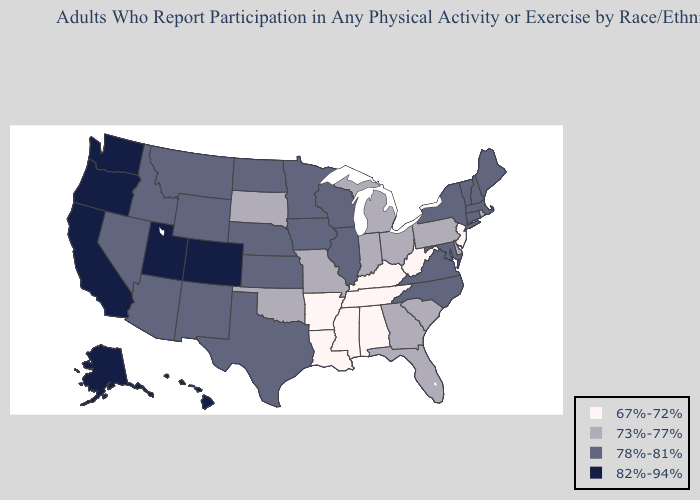Among the states that border Illinois , does Kentucky have the highest value?
Concise answer only. No. Name the states that have a value in the range 78%-81%?
Concise answer only. Arizona, Connecticut, Idaho, Illinois, Iowa, Kansas, Maine, Maryland, Massachusetts, Minnesota, Montana, Nebraska, Nevada, New Hampshire, New Mexico, New York, North Carolina, North Dakota, Texas, Vermont, Virginia, Wisconsin, Wyoming. Which states have the lowest value in the USA?
Concise answer only. Alabama, Arkansas, Kentucky, Louisiana, Mississippi, New Jersey, Tennessee, West Virginia. Name the states that have a value in the range 82%-94%?
Concise answer only. Alaska, California, Colorado, Hawaii, Oregon, Utah, Washington. What is the highest value in the Northeast ?
Quick response, please. 78%-81%. What is the value of Kansas?
Short answer required. 78%-81%. Among the states that border Florida , which have the lowest value?
Give a very brief answer. Alabama. Which states have the lowest value in the USA?
Be succinct. Alabama, Arkansas, Kentucky, Louisiana, Mississippi, New Jersey, Tennessee, West Virginia. What is the lowest value in states that border North Dakota?
Short answer required. 73%-77%. What is the value of Alabama?
Give a very brief answer. 67%-72%. Among the states that border Louisiana , does Texas have the lowest value?
Answer briefly. No. What is the value of Florida?
Short answer required. 73%-77%. Does Colorado have the highest value in the USA?
Write a very short answer. Yes. Among the states that border Alabama , does Mississippi have the highest value?
Short answer required. No. What is the highest value in the South ?
Answer briefly. 78%-81%. 